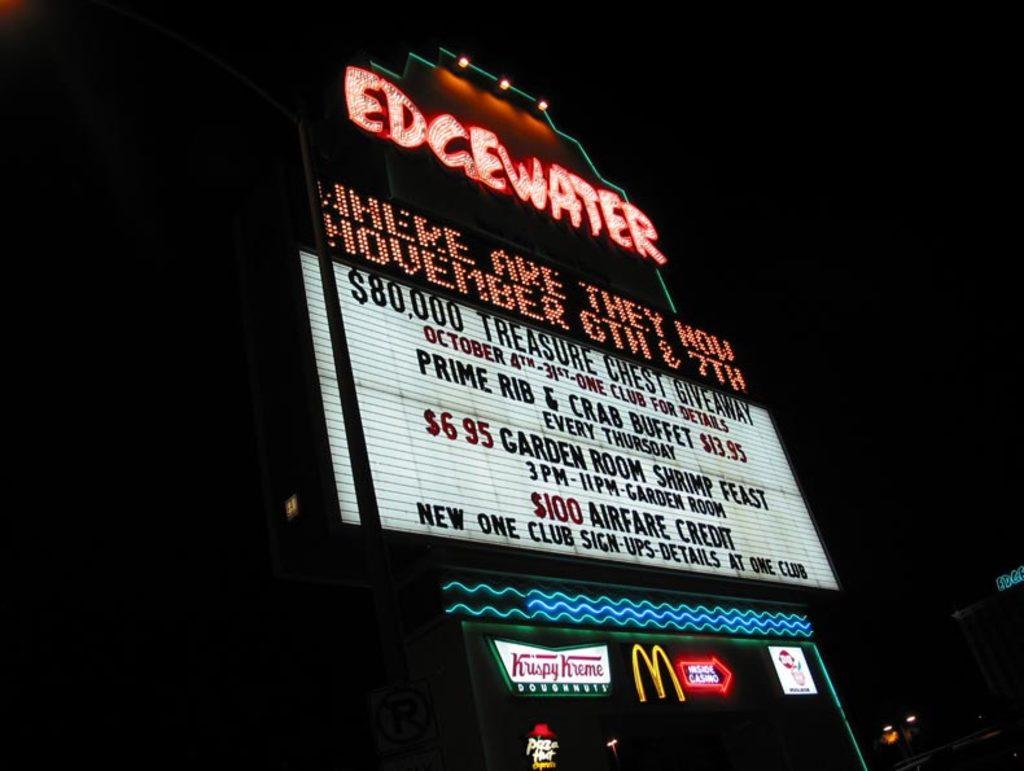What location is this?
Your answer should be very brief. Edgewater. 